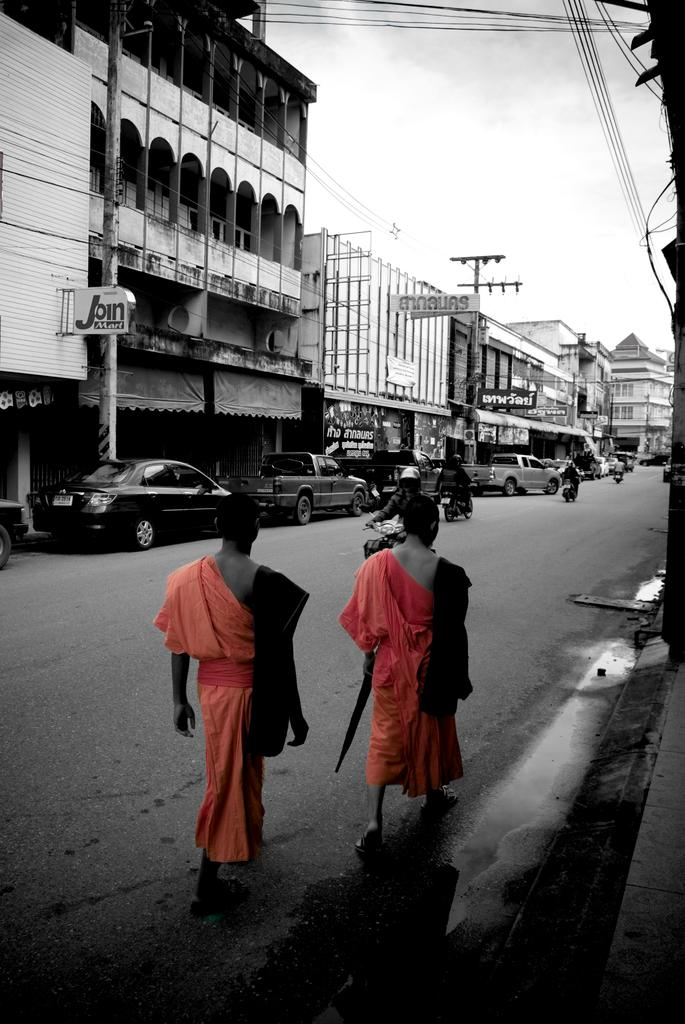What are the two persons in the foreground of the image doing? They are walking in the foreground of the image. Where are the two persons walking? They are walking beside a road. What can be seen in the background of the image? There are buildings, vehicles, and poles visible in the background of the image. What is present on top of the image? Cables are visible on top of the image. What is visible in the sky in the image? The sky is visible in the image. What type of crayon is being used by the person walking in the image? There is no crayon present in the image, and therefore no such activity can be observed. Can you tell me how many apples are on the wall in the image? There is no wall or apples present in the image. 